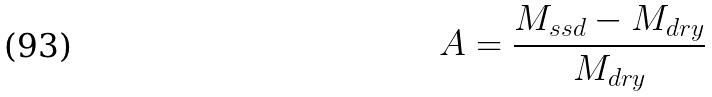<formula> <loc_0><loc_0><loc_500><loc_500>A = \frac { M _ { s s d } - M _ { d r y } } { M _ { d r y } }</formula> 